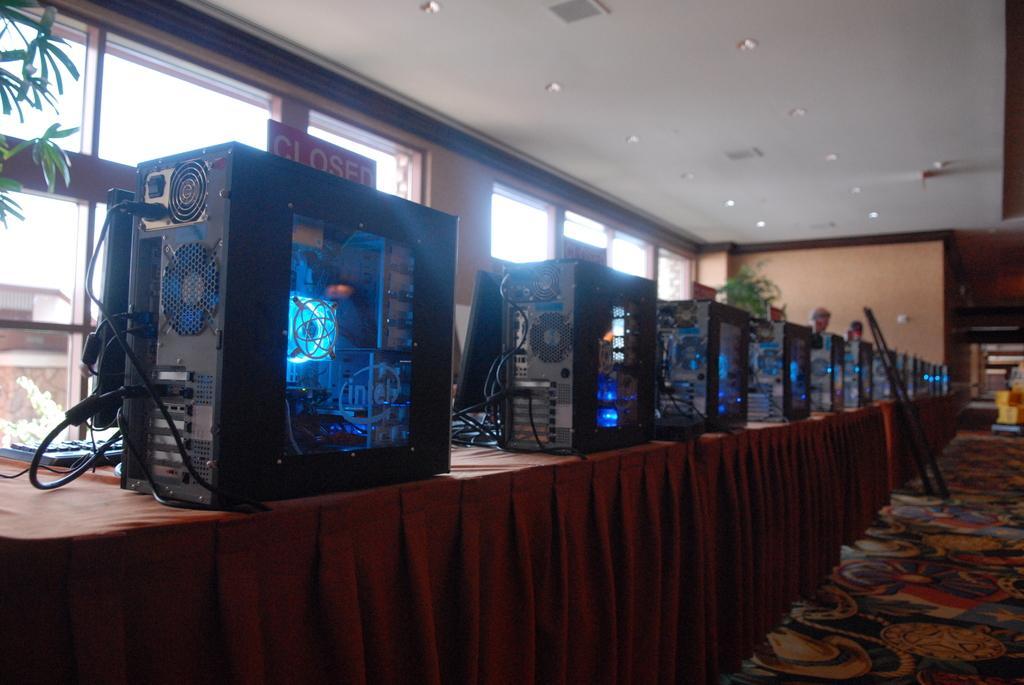Could you give a brief overview of what you see in this image? In this image there are a few objects are arranged on the table. On the right side of the image we can see the leaves of a tree, there are a few people standing behind the table. In the background there is a wall with windows. At the top of the image there is a ceiling with lights. 